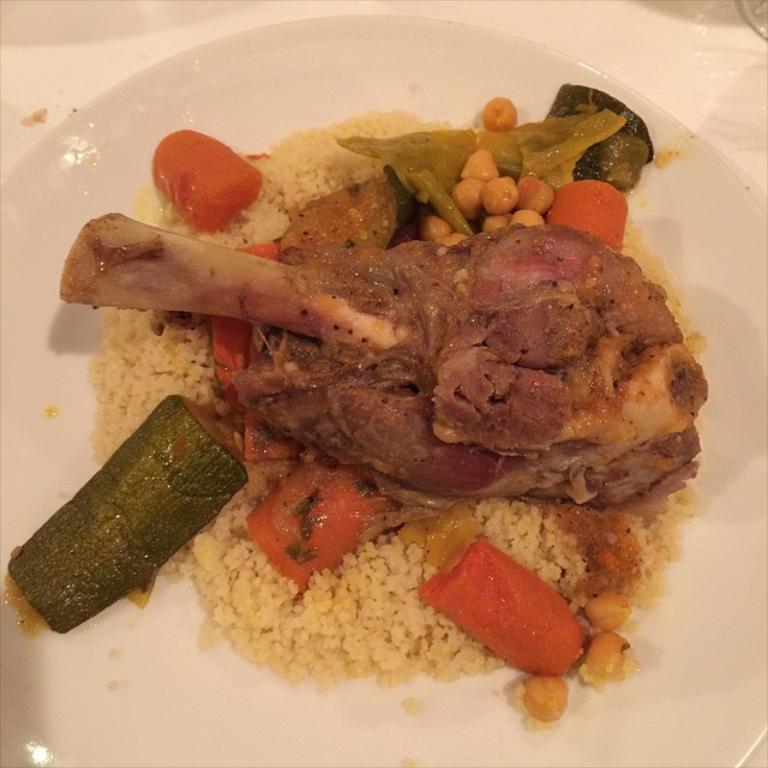Describe this image in one or two sentences. In the picture I can see the food item on the plate and looks like the plate is kept on the table. 